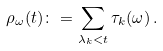<formula> <loc_0><loc_0><loc_500><loc_500>\rho _ { \omega } ( t ) \colon = \sum _ { \lambda _ { k } < t } \tau _ { k } ( \omega ) \, .</formula> 